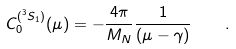Convert formula to latex. <formula><loc_0><loc_0><loc_500><loc_500>C _ { 0 } ^ { ( ^ { 3 } S _ { 1 } ) } ( \mu ) = - \frac { 4 \pi } { M _ { N } } \frac { 1 } { \left ( \mu - \gamma \right ) } \quad .</formula> 